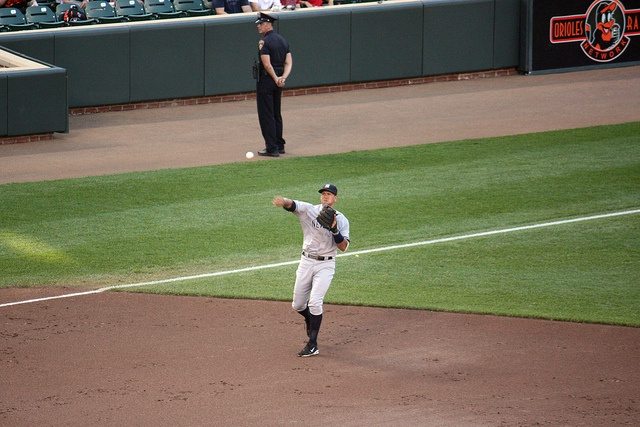Describe the objects in this image and their specific colors. I can see people in gray, lightgray, darkgray, and black tones, people in gray, black, and tan tones, chair in gray, teal, and black tones, chair in gray, black, and teal tones, and chair in gray, teal, and black tones in this image. 